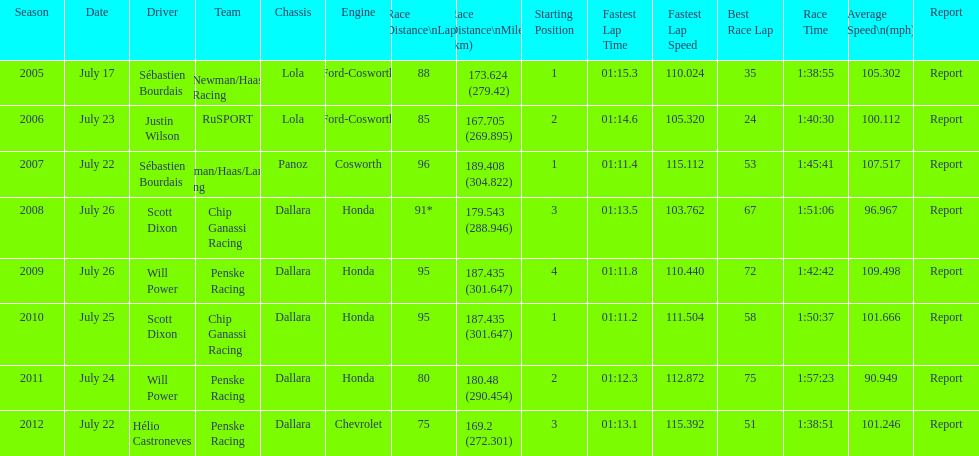How many different teams are represented in the table? 4. 